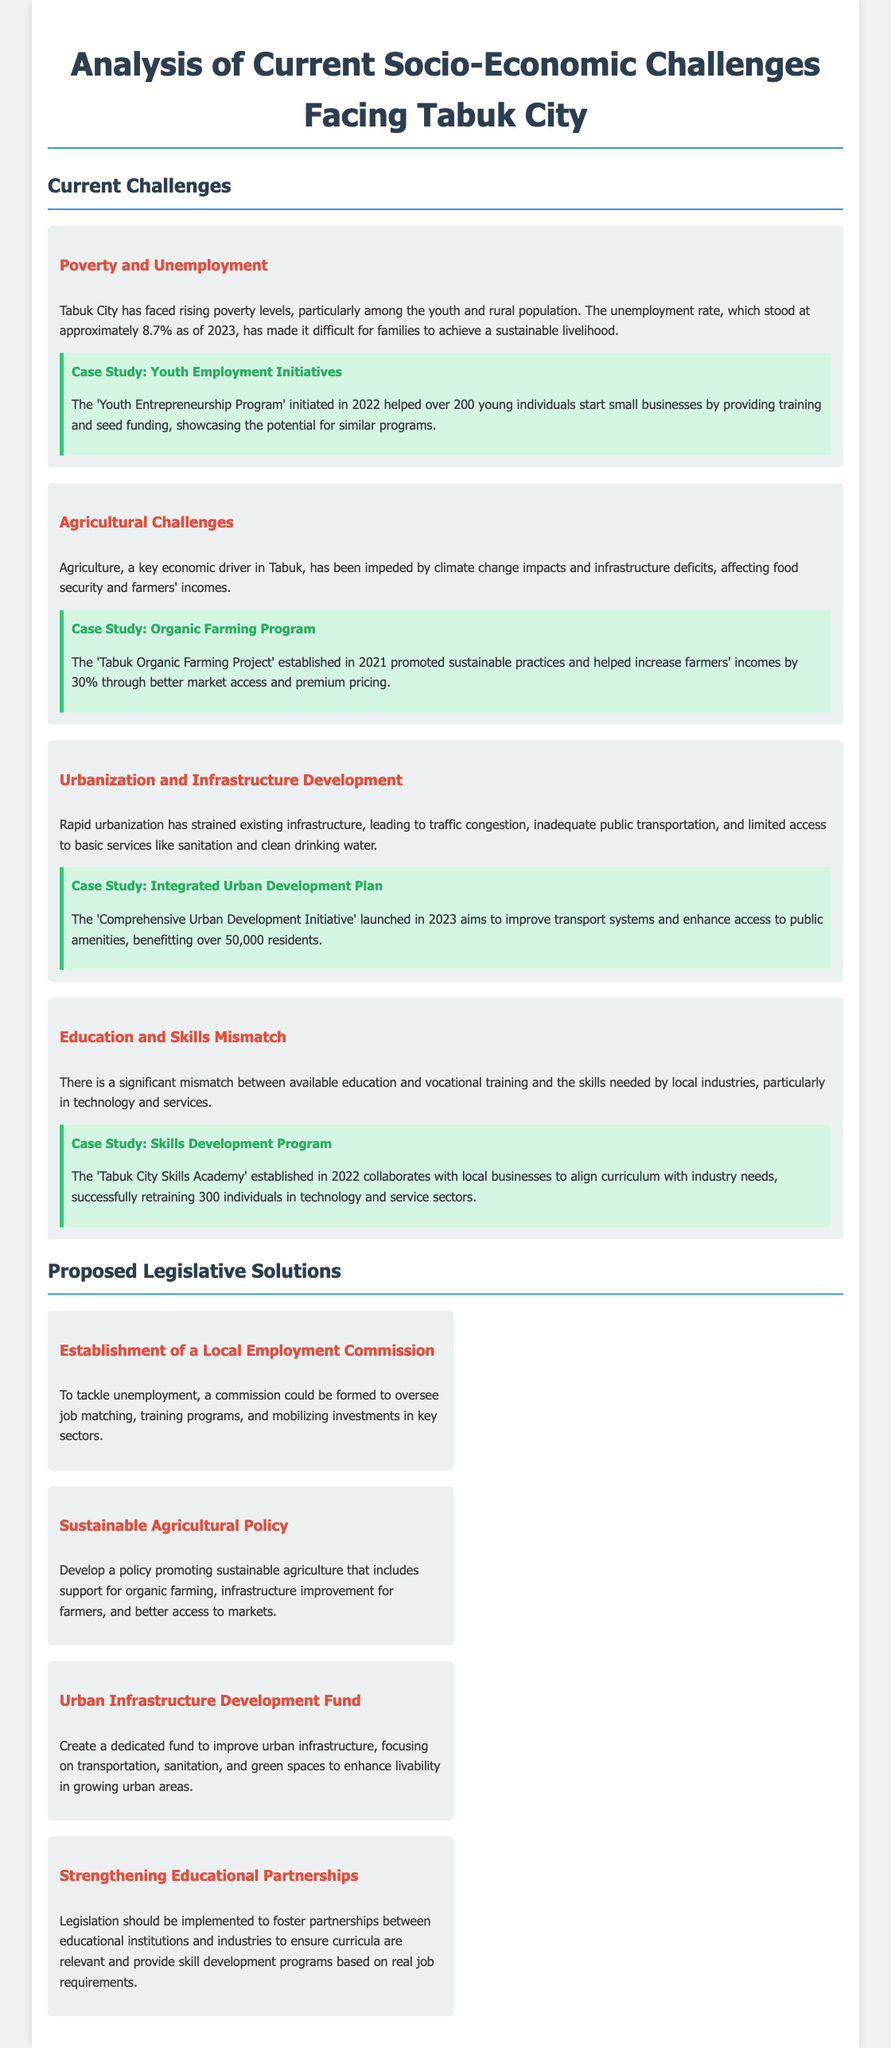What is the unemployment rate in Tabuk City as of 2023? The unemployment rate as stated in the document is approximately 8.7%.
Answer: 8.7% What program helped over 200 young individuals start small businesses? The document mentions the 'Youth Entrepreneurship Program' initiated in 2022.
Answer: Youth Entrepreneurship Program What percentage increase in farmer incomes was achieved through the 'Tabuk Organic Farming Project'? According to the case study, farmers' incomes increased by 30%.
Answer: 30% What initiative was launched in 2023 to improve urban transport systems? The document refers to the 'Comprehensive Urban Development Initiative' aimed at transport improvements.
Answer: Comprehensive Urban Development Initiative Which program retrained 300 individuals in technology and service sectors? This information pertains to the 'Tabuk City Skills Academy' established in 2022.
Answer: Tabuk City Skills Academy What type of fund is proposed to improve urban infrastructure? The document suggests creating an 'Urban Infrastructure Development Fund'.
Answer: Urban Infrastructure Development Fund What policy is proposed to support sustainable agriculture? A 'Sustainable Agricultural Policy' is proposed for supporting organic farming and infrastructure improvement.
Answer: Sustainable Agricultural Policy Which program promotes partnerships between educational institutions and industries? The proposed legislation is focused on 'Strengthening Educational Partnerships'.
Answer: Strengthening Educational Partnerships 